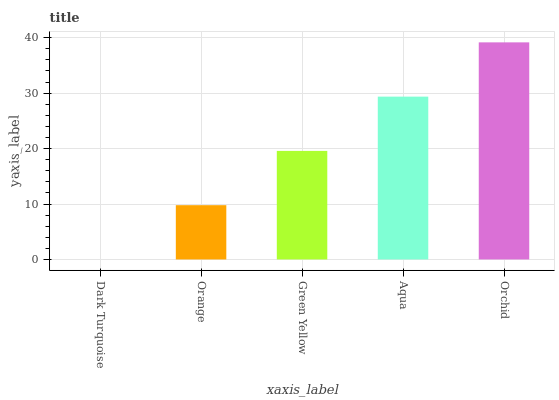Is Dark Turquoise the minimum?
Answer yes or no. Yes. Is Orchid the maximum?
Answer yes or no. Yes. Is Orange the minimum?
Answer yes or no. No. Is Orange the maximum?
Answer yes or no. No. Is Orange greater than Dark Turquoise?
Answer yes or no. Yes. Is Dark Turquoise less than Orange?
Answer yes or no. Yes. Is Dark Turquoise greater than Orange?
Answer yes or no. No. Is Orange less than Dark Turquoise?
Answer yes or no. No. Is Green Yellow the high median?
Answer yes or no. Yes. Is Green Yellow the low median?
Answer yes or no. Yes. Is Orchid the high median?
Answer yes or no. No. Is Aqua the low median?
Answer yes or no. No. 